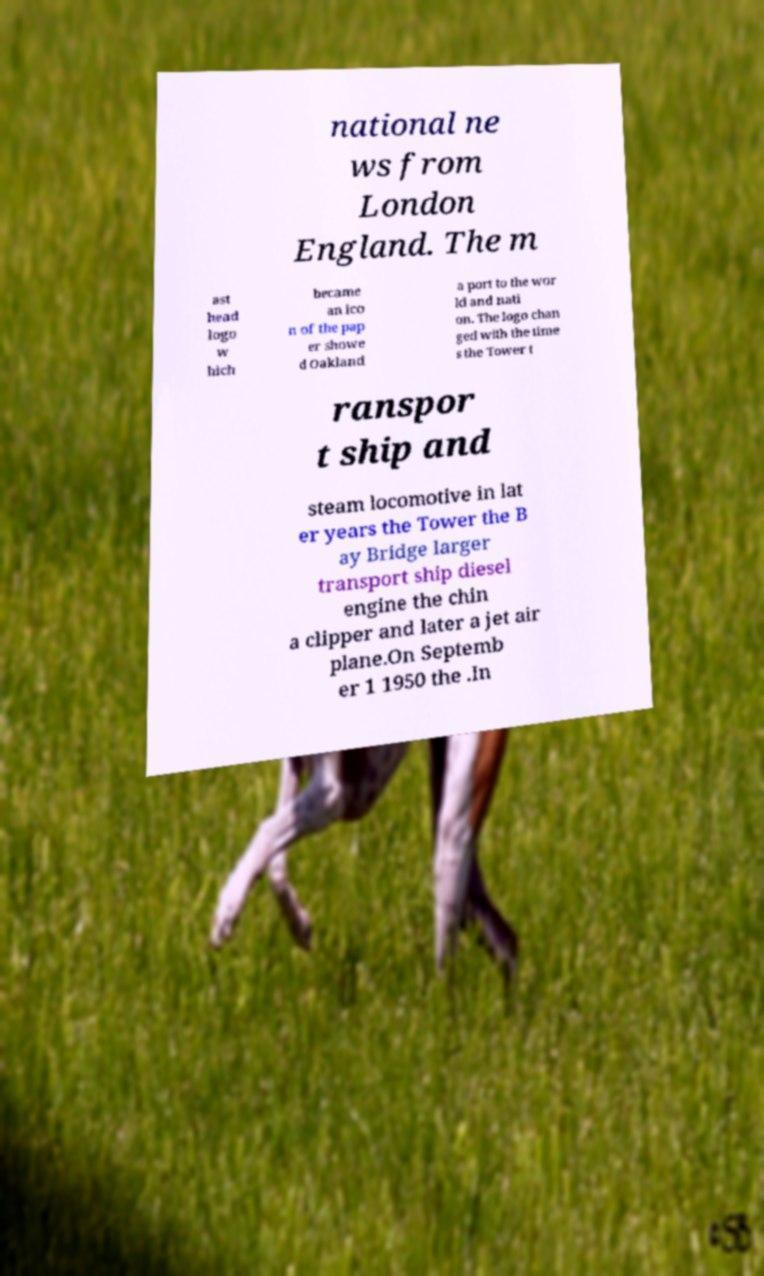Can you accurately transcribe the text from the provided image for me? national ne ws from London England. The m ast head logo w hich became an ico n of the pap er showe d Oakland a port to the wor ld and nati on. The logo chan ged with the time s the Tower t ranspor t ship and steam locomotive in lat er years the Tower the B ay Bridge larger transport ship diesel engine the chin a clipper and later a jet air plane.On Septemb er 1 1950 the .In 